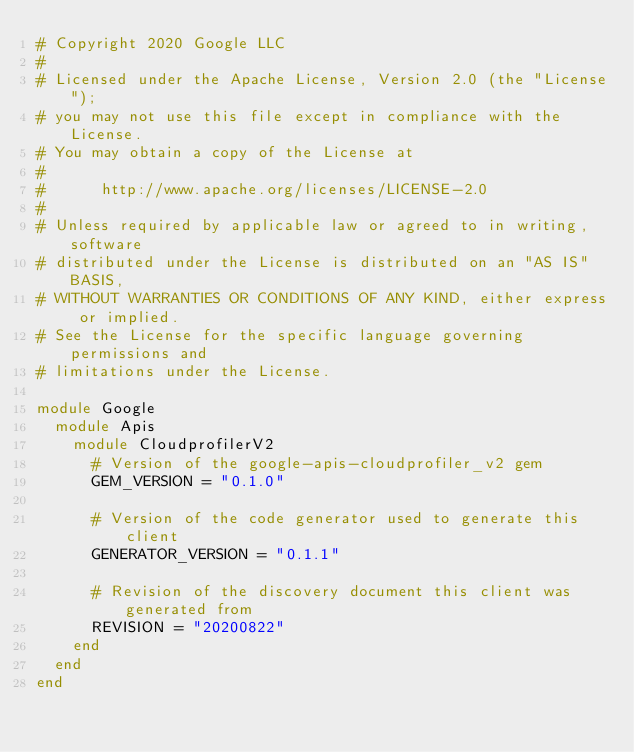<code> <loc_0><loc_0><loc_500><loc_500><_Ruby_># Copyright 2020 Google LLC
#
# Licensed under the Apache License, Version 2.0 (the "License");
# you may not use this file except in compliance with the License.
# You may obtain a copy of the License at
#
#      http://www.apache.org/licenses/LICENSE-2.0
#
# Unless required by applicable law or agreed to in writing, software
# distributed under the License is distributed on an "AS IS" BASIS,
# WITHOUT WARRANTIES OR CONDITIONS OF ANY KIND, either express or implied.
# See the License for the specific language governing permissions and
# limitations under the License.

module Google
  module Apis
    module CloudprofilerV2
      # Version of the google-apis-cloudprofiler_v2 gem
      GEM_VERSION = "0.1.0"

      # Version of the code generator used to generate this client
      GENERATOR_VERSION = "0.1.1"

      # Revision of the discovery document this client was generated from
      REVISION = "20200822"
    end
  end
end
</code> 